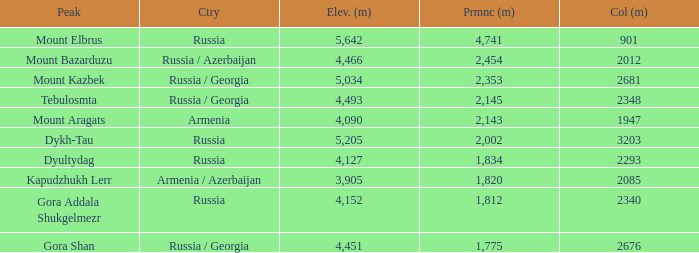With a Col (m) larger than 2012, what is Mount Kazbek's Prominence (m)? 2353.0. Give me the full table as a dictionary. {'header': ['Peak', 'Ctry', 'Elev. (m)', 'Prmnc (m)', 'Col (m)'], 'rows': [['Mount Elbrus', 'Russia', '5,642', '4,741', '901'], ['Mount Bazarduzu', 'Russia / Azerbaijan', '4,466', '2,454', '2012'], ['Mount Kazbek', 'Russia / Georgia', '5,034', '2,353', '2681'], ['Tebulosmta', 'Russia / Georgia', '4,493', '2,145', '2348'], ['Mount Aragats', 'Armenia', '4,090', '2,143', '1947'], ['Dykh-Tau', 'Russia', '5,205', '2,002', '3203'], ['Dyultydag', 'Russia', '4,127', '1,834', '2293'], ['Kapudzhukh Lerr', 'Armenia / Azerbaijan', '3,905', '1,820', '2085'], ['Gora Addala Shukgelmezr', 'Russia', '4,152', '1,812', '2340'], ['Gora Shan', 'Russia / Georgia', '4,451', '1,775', '2676']]} 